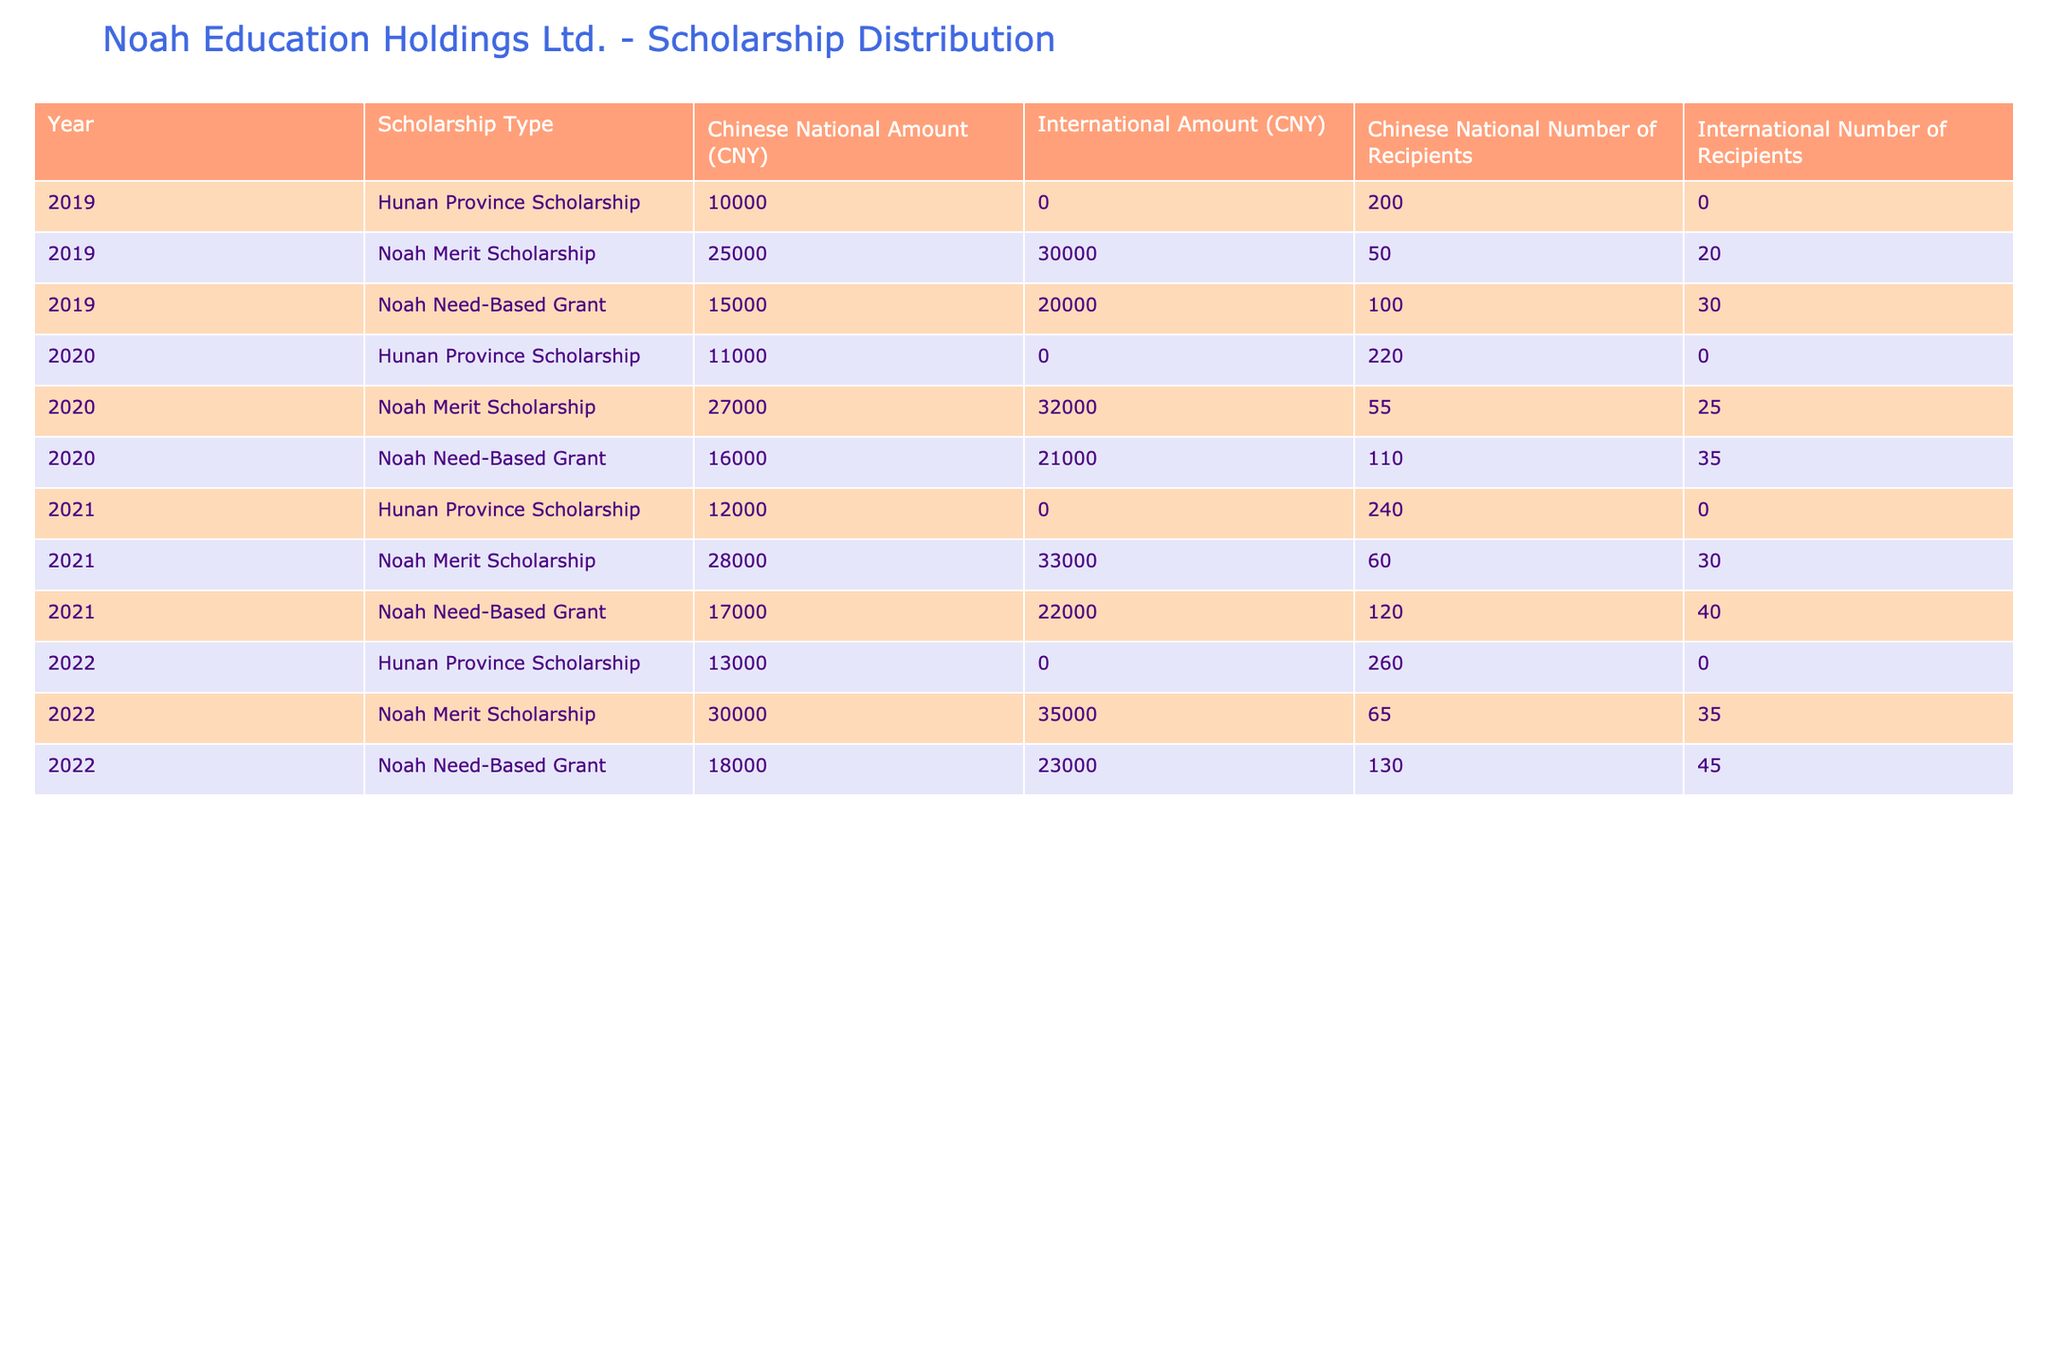What is the total amount allocated for Noah Merit Scholarships in 2019? In 2019, the total amount allocated for Noah Merit Scholarships can be found by looking at the row for this scholarship type. The amount allocated for Chinese National recipients is 25000 CNY and for International recipients it is 30000 CNY. Adding these amounts gives 25000 + 30000 = 55000 CNY.
Answer: 55000 CNY How many recipients were awarded Noah Need-Based Grants in 2020? The number of recipients for Noah Need-Based Grants in 2020 can be found in the corresponding rows. For Chinese National recipients, there were 110 recipients, and for International recipients, there were 35. Summing these gives 110 + 35 = 145 recipients.
Answer: 145 recipients Is the GPA requirement for Hunan Province Scholarships higher for Chinese National or International students? The GPA requirements for Hunan Province Scholarships are consistent at 3.5 for all entries of Chinese National and International students across the years. Thus, they are equal, meaning the requirement is not higher for one over the other.
Answer: No Which year had the highest total amount allocated for Noah Merit Scholarships? By examining the amounts allocated for Noah Merit Scholarships across the years, the values are: 2019 = 55000 CNY, 2020 = 59000 CNY (27000 + 32000), 2021 = 61000 CNY (28000 + 33000), and 2022 = 65000 CNY (30000 + 35000). The highest total amount is 65000 CNY in 2022.
Answer: 2022 What is the difference between the number of recipients for Noah Need-Based Grants for Chinese National students in 2021 and 2019? In 2021, the number of recipients for Noah Need-Based Grants for Chinese National students is 120, and in 2019 it is 100. To find the difference, we subtract the two: 120 - 100 = 20.
Answer: 20 recipients How many more recipients received Hunan Province Scholarships compared to Noah Merit Scholarships in 2021? In 2021, the number of recipients for Hunan Province Scholarships for Chinese National students is 240 and for Noah Merit Scholarships it is 60 (for Chinese National). To find how many more recipients received Hunan Province Scholarships, we calculate 240 - 60 = 180.
Answer: 180 recipients Is it true that the amount for Noah Need-Based Grants increased every year for both demographics? Reviewing the amounts allocated for Noah Need-Based Grants, for Chinese Nationals: 15000 (2019), 16000 (2020), 17000 (2021), and 18000 (2022) shows an increase each year. For International recipients: 20000 (2019), 21000 (2020), 22000 (2021), 23000 (2022), also shows an increase. Therefore, the statement is true.
Answer: Yes What is the highest GPA requirement for any Scholarship Type across all years? Looking at the GPA requirements across all scholarship types and years, the highest GPA requirement is 3.9, which requires for both the Noah Merit Scholarship and International demographic in multiple years. There are no higher requirements than this.
Answer: 3.9 